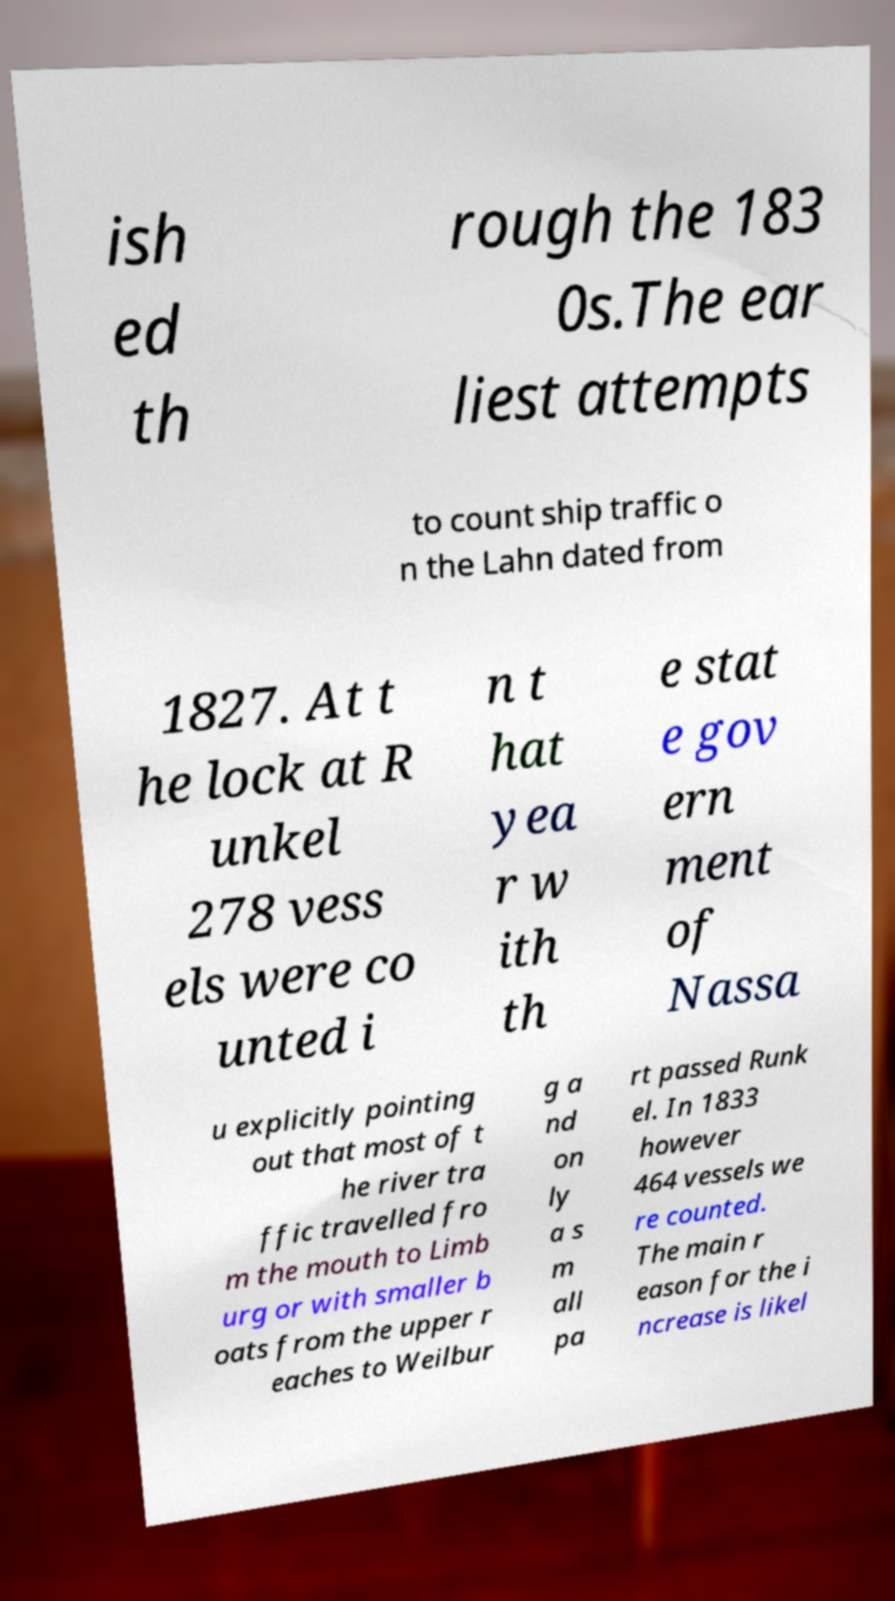Can you accurately transcribe the text from the provided image for me? ish ed th rough the 183 0s.The ear liest attempts to count ship traffic o n the Lahn dated from 1827. At t he lock at R unkel 278 vess els were co unted i n t hat yea r w ith th e stat e gov ern ment of Nassa u explicitly pointing out that most of t he river tra ffic travelled fro m the mouth to Limb urg or with smaller b oats from the upper r eaches to Weilbur g a nd on ly a s m all pa rt passed Runk el. In 1833 however 464 vessels we re counted. The main r eason for the i ncrease is likel 